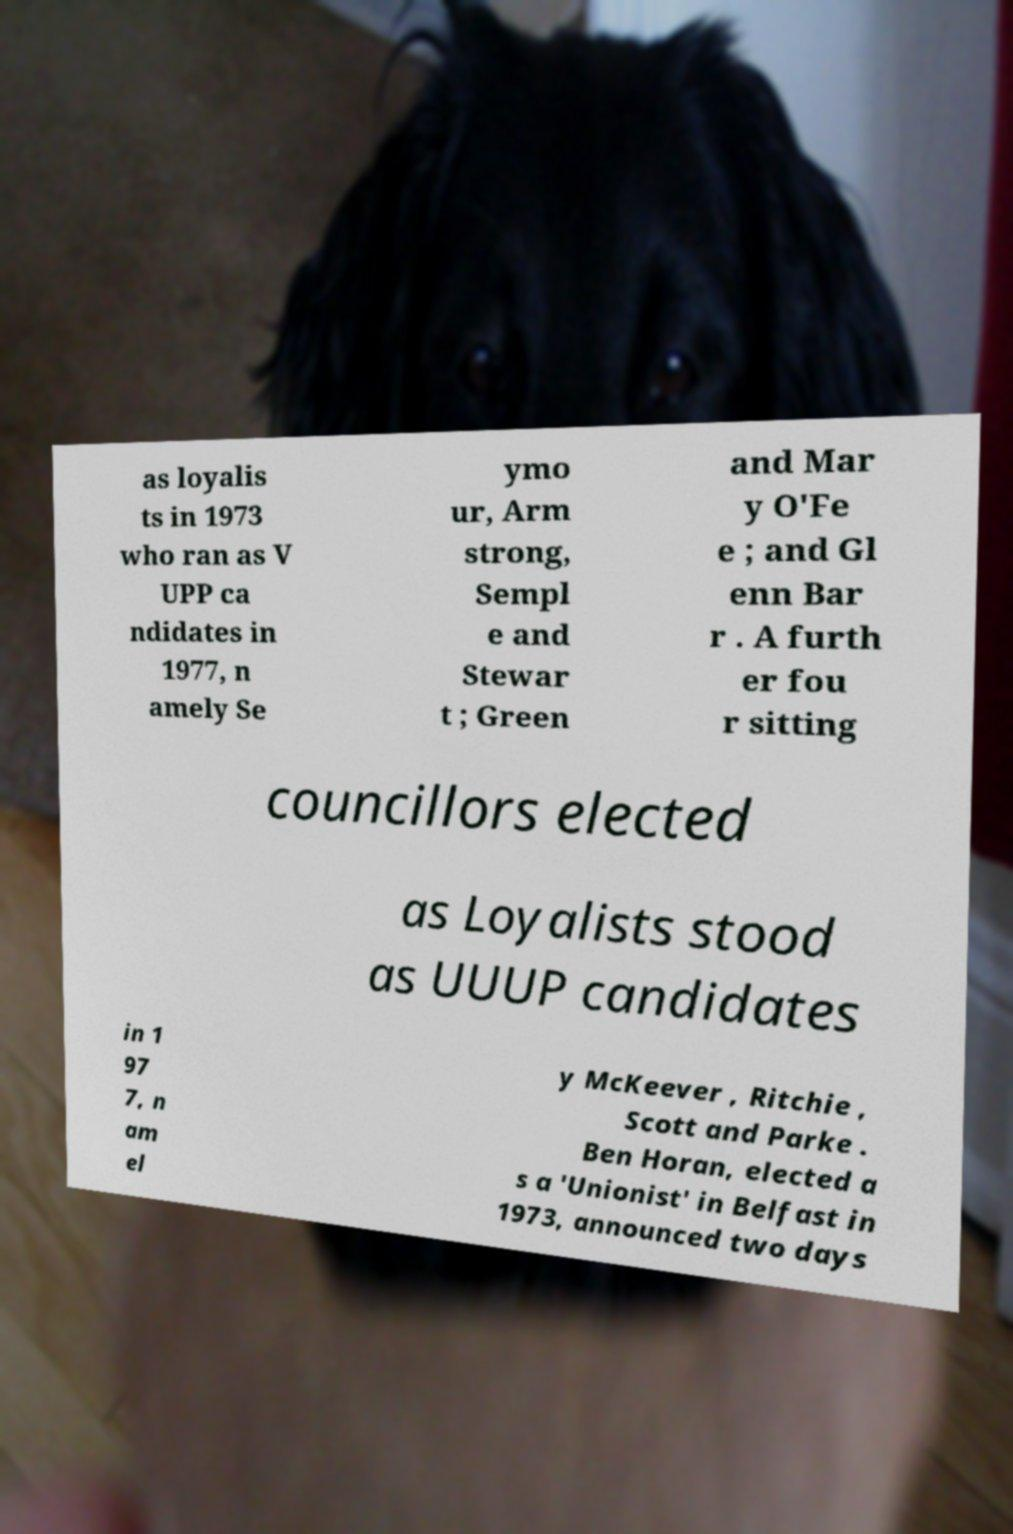There's text embedded in this image that I need extracted. Can you transcribe it verbatim? as loyalis ts in 1973 who ran as V UPP ca ndidates in 1977, n amely Se ymo ur, Arm strong, Sempl e and Stewar t ; Green and Mar y O'Fe e ; and Gl enn Bar r . A furth er fou r sitting councillors elected as Loyalists stood as UUUP candidates in 1 97 7, n am el y McKeever , Ritchie , Scott and Parke . Ben Horan, elected a s a 'Unionist' in Belfast in 1973, announced two days 